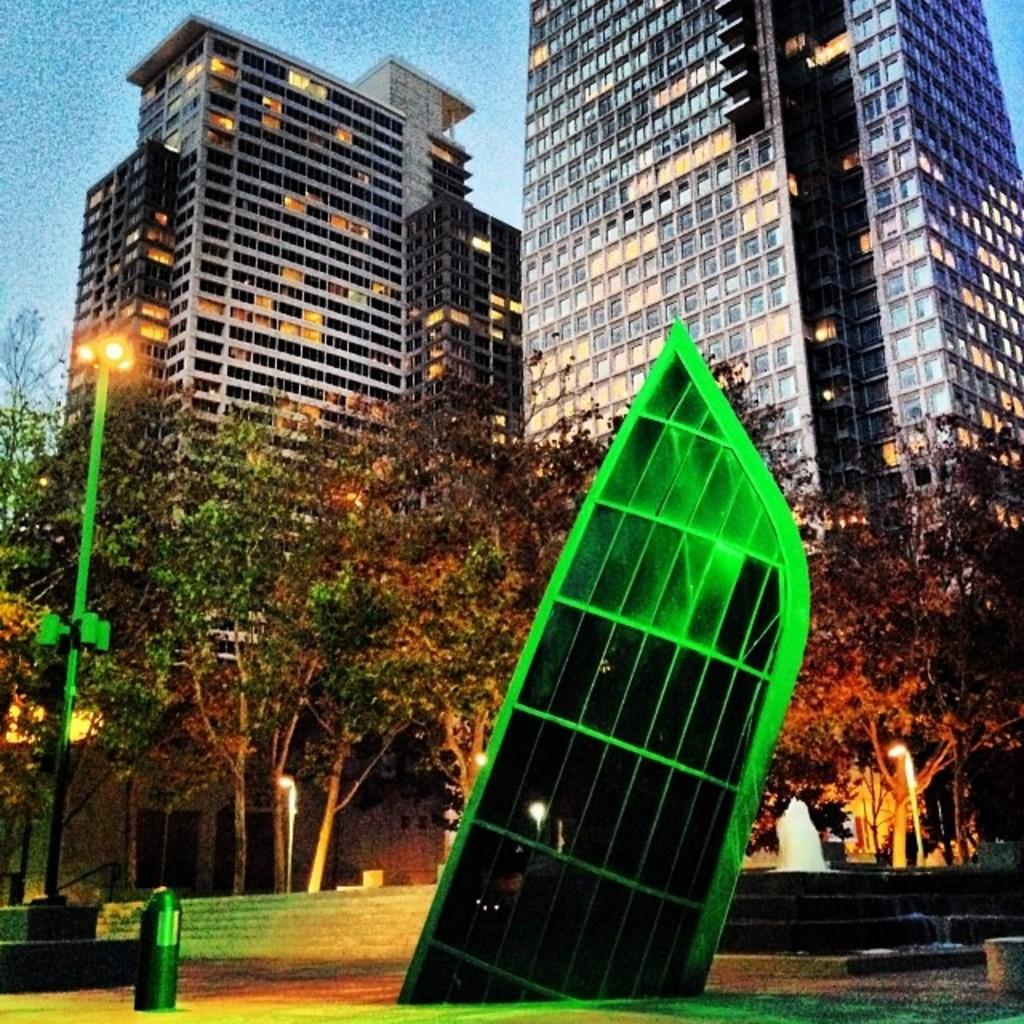What type of natural elements can be seen in the image? There are trees in the image. What type of man-made structures are present in the image? There are buildings in the image. What objects are supporting the lights in the image? There are poles in the image. What type of illumination is present in the image? There are lights in the image. How many clocks are hanging from the trees in the image? There are no clocks present in the image; it features trees, buildings, poles, and lights. What type of mark can be seen on the buildings in the image? There is no specific mark mentioned on the buildings in the image. 